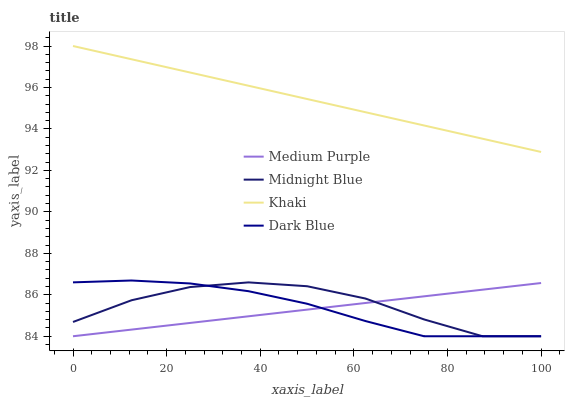Does Dark Blue have the minimum area under the curve?
Answer yes or no. No. Does Dark Blue have the maximum area under the curve?
Answer yes or no. No. Is Dark Blue the smoothest?
Answer yes or no. No. Is Dark Blue the roughest?
Answer yes or no. No. Does Khaki have the lowest value?
Answer yes or no. No. Does Dark Blue have the highest value?
Answer yes or no. No. Is Midnight Blue less than Khaki?
Answer yes or no. Yes. Is Khaki greater than Medium Purple?
Answer yes or no. Yes. Does Midnight Blue intersect Khaki?
Answer yes or no. No. 